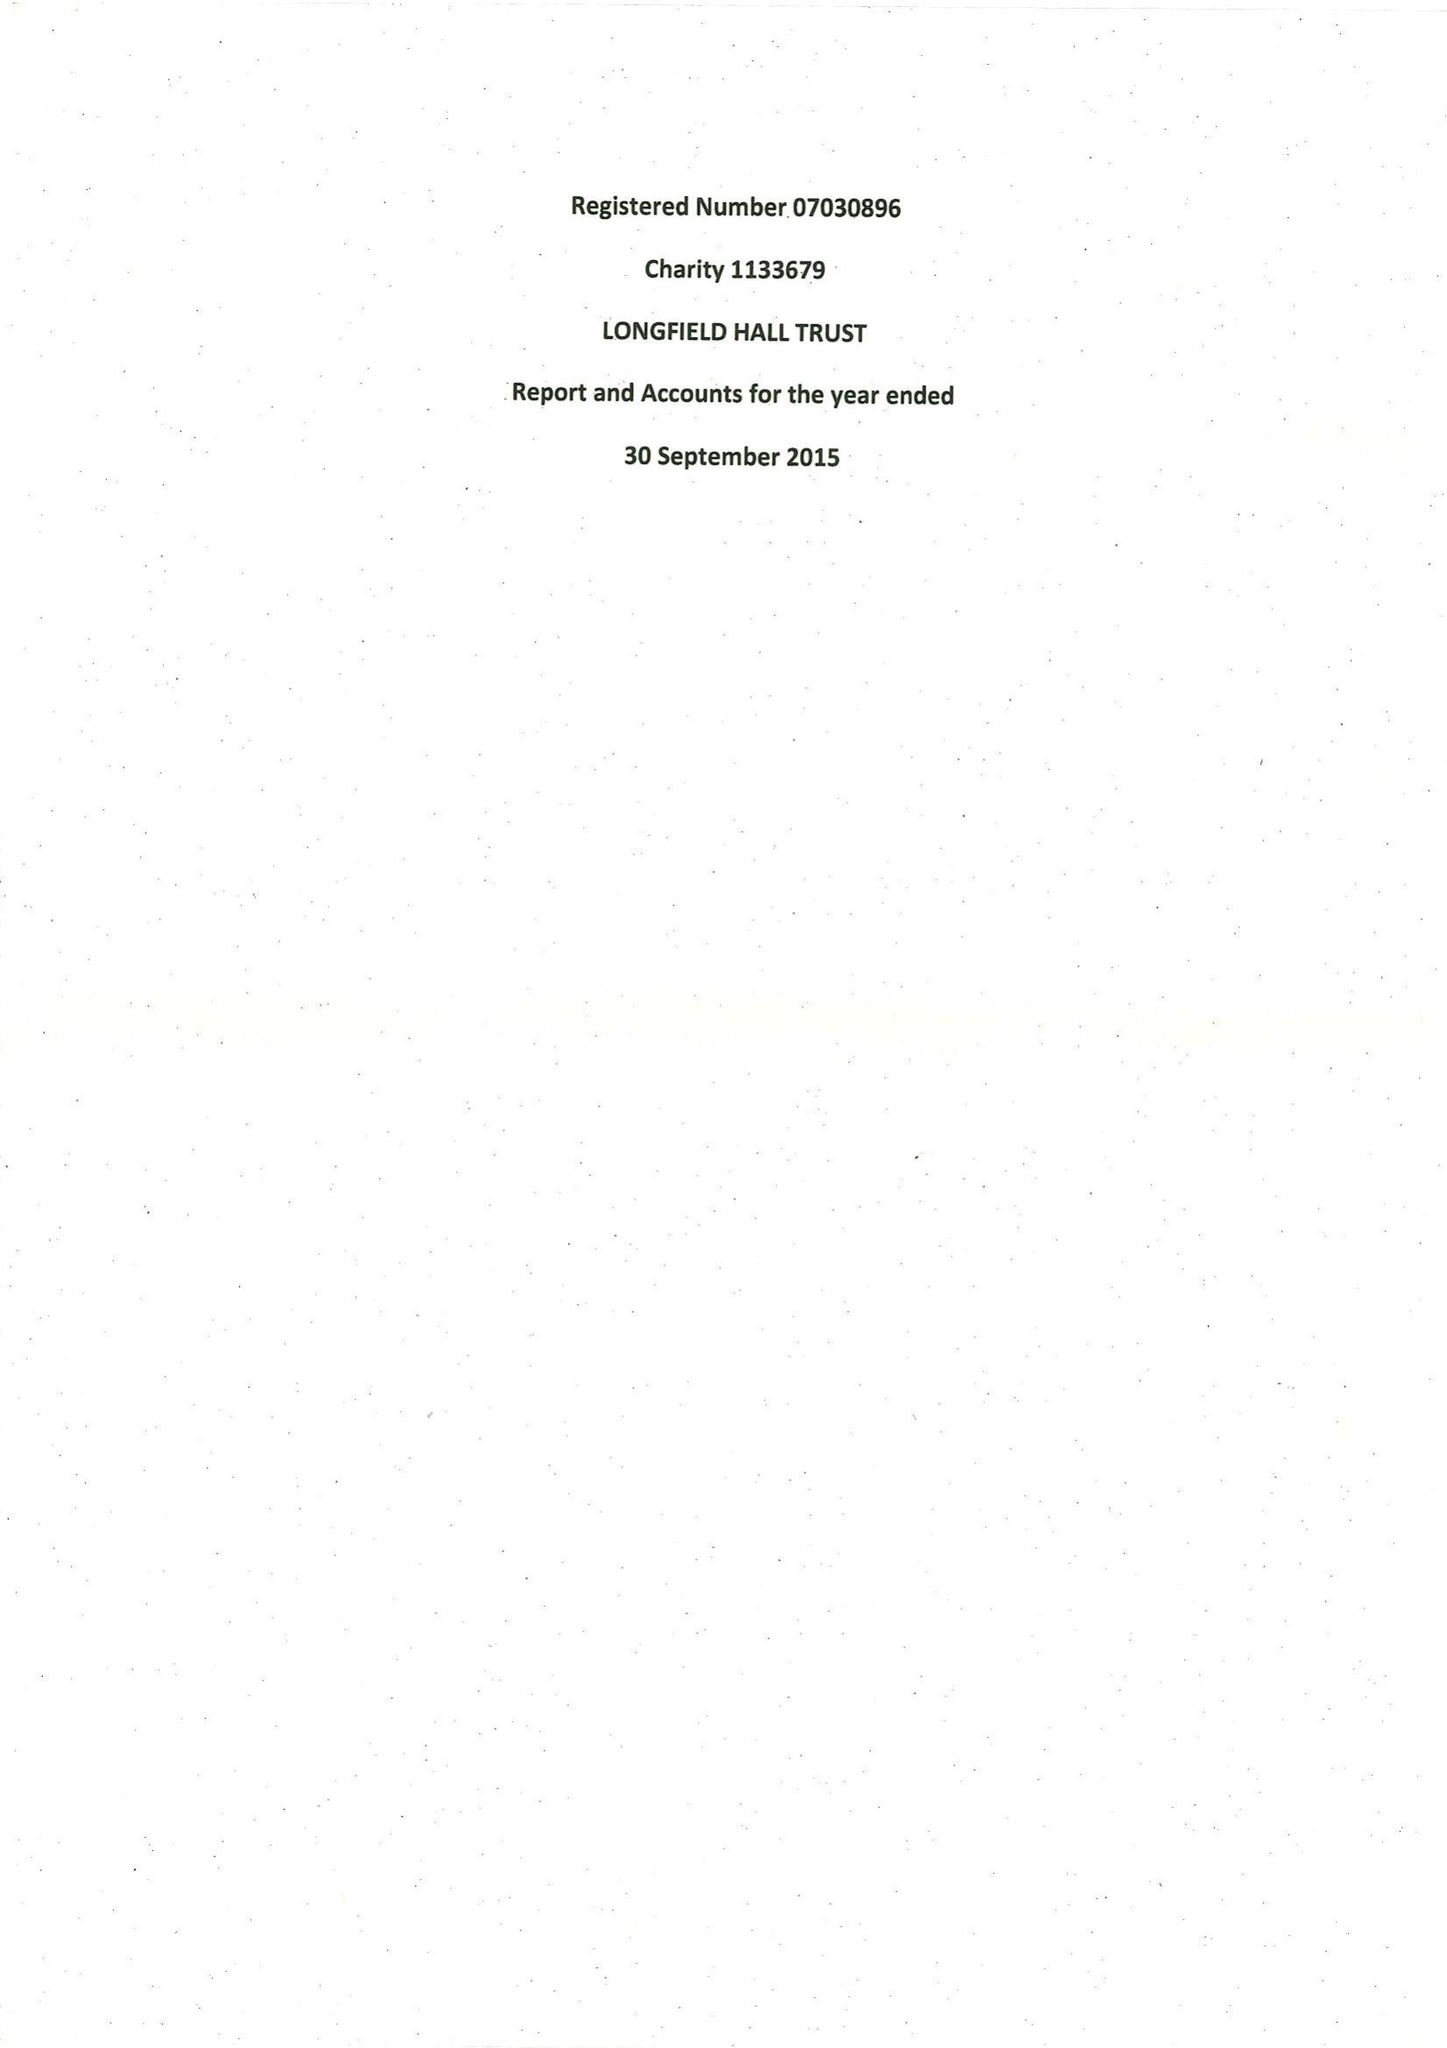What is the value for the address__postcode?
Answer the question using a single word or phrase. SE5 9QY 